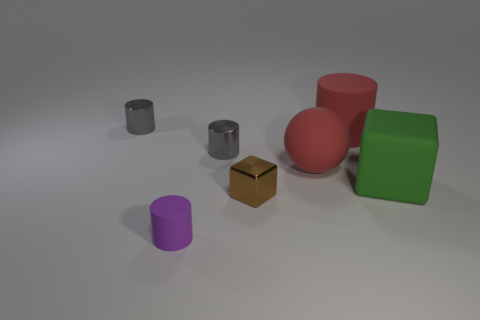There is a large green thing; what shape is it?
Offer a terse response. Cube. How many small things are green things or rubber cylinders?
Offer a very short reply. 1. There is a brown object that is the same shape as the green thing; what size is it?
Offer a very short reply. Small. What number of tiny objects are both behind the small purple rubber cylinder and on the left side of the brown metal thing?
Your answer should be very brief. 2. Does the small purple rubber object have the same shape as the object behind the large matte cylinder?
Your answer should be compact. Yes. Is the number of tiny things that are behind the large green rubber thing greater than the number of yellow metal spheres?
Give a very brief answer. Yes. Are there fewer big green matte objects that are in front of the green thing than small gray cylinders?
Provide a short and direct response. Yes. How many large rubber things are the same color as the tiny metal cube?
Make the answer very short. 0. There is a cylinder that is both to the right of the purple object and on the left side of the large ball; what material is it made of?
Provide a succinct answer. Metal. There is a cylinder behind the large red cylinder; does it have the same color as the small metallic cylinder that is in front of the red matte cylinder?
Offer a terse response. Yes. 